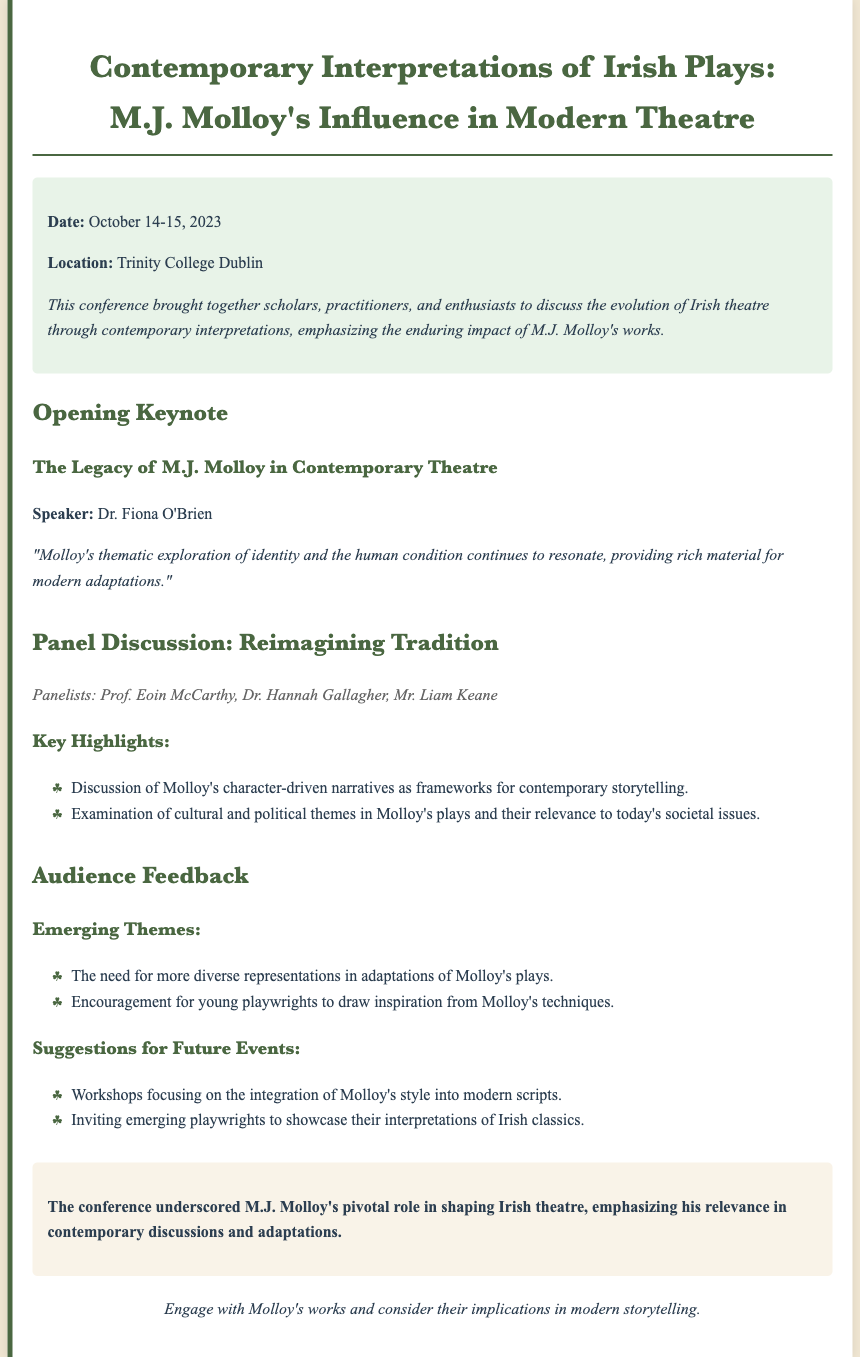What are the dates of the conference? The dates for the conference are mentioned in the document under the conference info section.
Answer: October 14-15, 2023 Who delivered the opening keynote? The document specifies the speaker of the opening keynote in the section about the keynote.
Answer: Dr. Fiona O'Brien What is the location of the conference? The location of the conference is provided in the conference information section of the document.
Answer: Trinity College Dublin What thematic exploration does Molloy emphasize? The document notes the thematic focus of Molloy's work highlighted by the keynote speaker.
Answer: Identity and the human condition Which panelist is mentioned first? The order of the panelists' names is presented in the panel discussion section.
Answer: Prof. Eoin McCarthy What key aspect of Molloy's narratives was discussed? The highlights of the panel discussion outline an important feature of Molloy's works.
Answer: Character-driven narratives What are the emerging themes from audience feedback? The document lists important themes noticed by the audience concerning Molloy's works.
Answer: Diverse representations What was a suggested future event topic? Suggestions for future events are mentioned in the audience feedback section of the document.
Answer: Workshops focusing on the integration of Molloy's style 